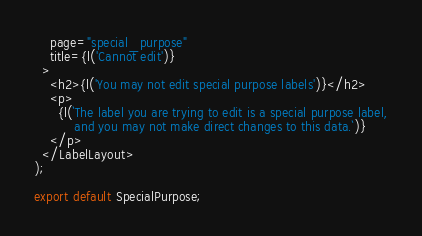<code> <loc_0><loc_0><loc_500><loc_500><_JavaScript_>    page="special_purpose"
    title={l('Cannot edit')}
  >
    <h2>{l('You may not edit special purpose labels')}</h2>
    <p>
      {l(`The label you are trying to edit is a special purpose label,
          and you may not make direct changes to this data.`)}
    </p>
  </LabelLayout>
);

export default SpecialPurpose;
</code> 